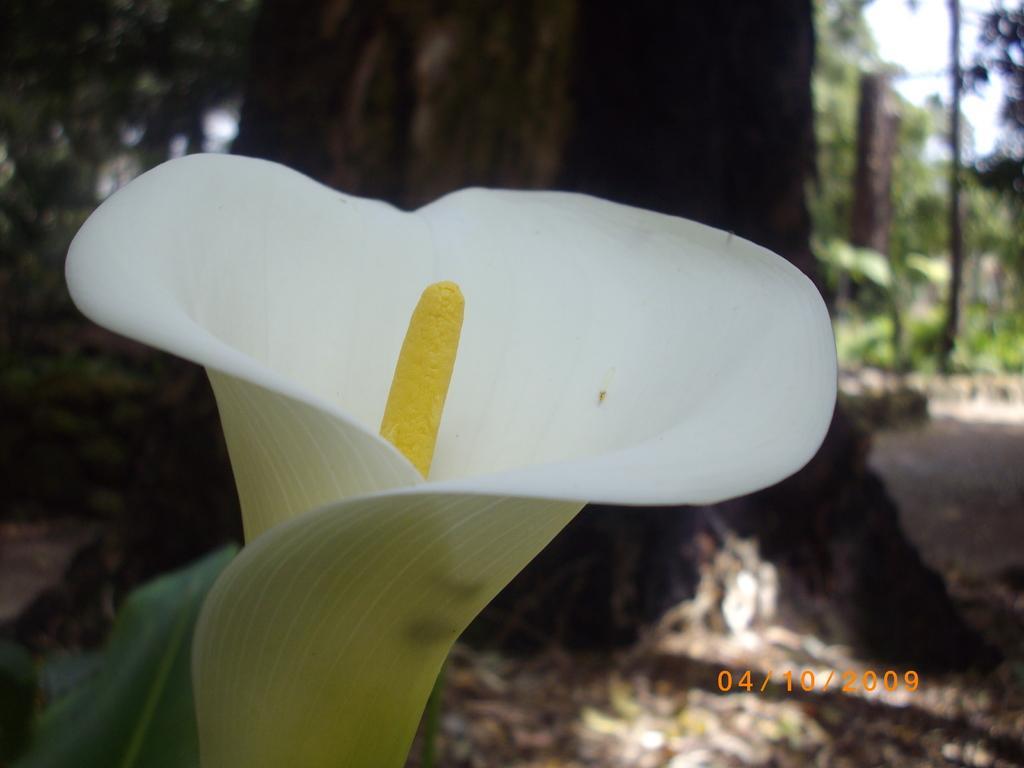Can you describe this image briefly? In this image we can see a flower which is in white color. In the background there are trees and sky. 